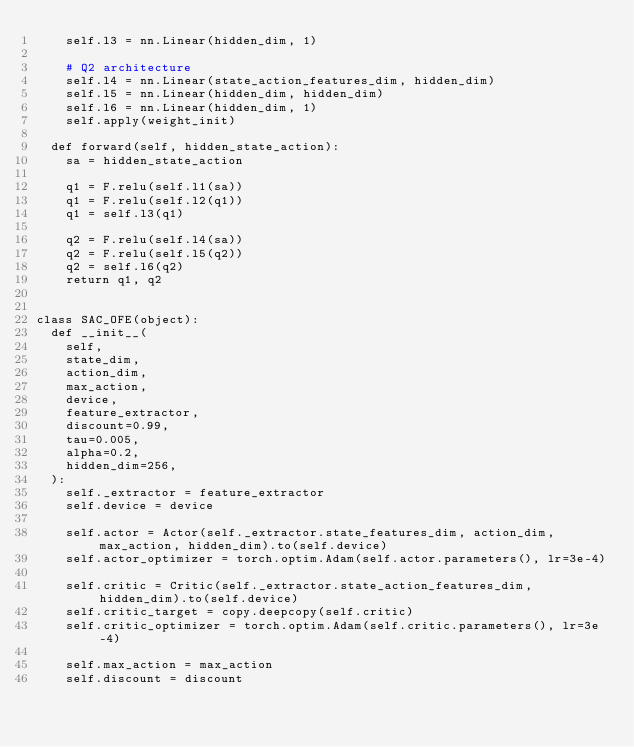Convert code to text. <code><loc_0><loc_0><loc_500><loc_500><_Python_>		self.l3 = nn.Linear(hidden_dim, 1)

		# Q2 architecture
		self.l4 = nn.Linear(state_action_features_dim, hidden_dim)
		self.l5 = nn.Linear(hidden_dim, hidden_dim)
		self.l6 = nn.Linear(hidden_dim, 1)
		self.apply(weight_init)

	def forward(self, hidden_state_action):
		sa = hidden_state_action

		q1 = F.relu(self.l1(sa))
		q1 = F.relu(self.l2(q1))
		q1 = self.l3(q1)

		q2 = F.relu(self.l4(sa))
		q2 = F.relu(self.l5(q2))
		q2 = self.l6(q2)
		return q1, q2


class SAC_OFE(object):
	def __init__(
		self,
		state_dim,
		action_dim,
		max_action,
		device,
		feature_extractor,
		discount=0.99,
		tau=0.005,
		alpha=0.2,
		hidden_dim=256,
	):
		self._extractor = feature_extractor
		self.device = device

		self.actor = Actor(self._extractor.state_features_dim, action_dim, max_action, hidden_dim).to(self.device)
		self.actor_optimizer = torch.optim.Adam(self.actor.parameters(), lr=3e-4)

		self.critic = Critic(self._extractor.state_action_features_dim, hidden_dim).to(self.device)
		self.critic_target = copy.deepcopy(self.critic)
		self.critic_optimizer = torch.optim.Adam(self.critic.parameters(), lr=3e-4)

		self.max_action = max_action
		self.discount = discount</code> 